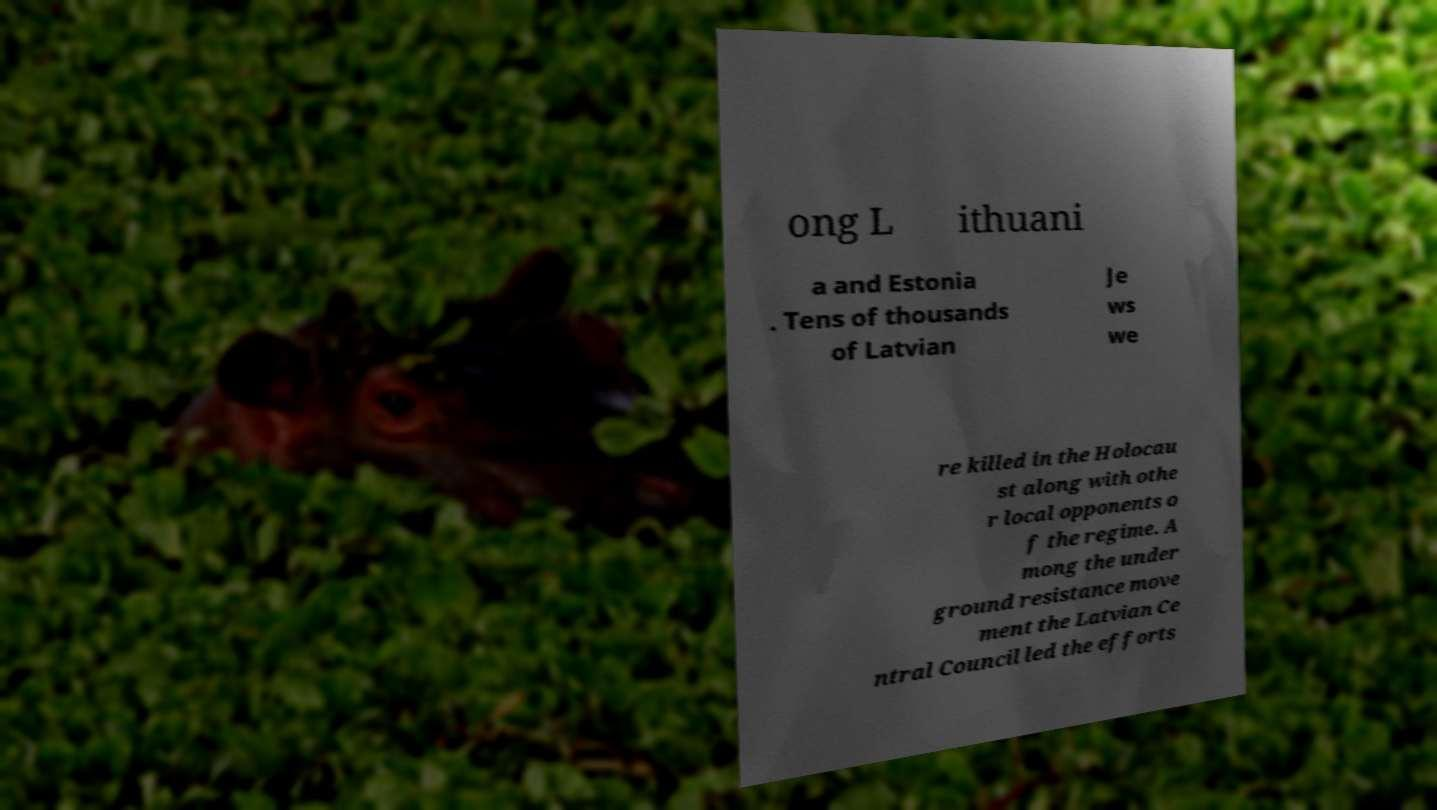Please identify and transcribe the text found in this image. ong L ithuani a and Estonia . Tens of thousands of Latvian Je ws we re killed in the Holocau st along with othe r local opponents o f the regime. A mong the under ground resistance move ment the Latvian Ce ntral Council led the efforts 